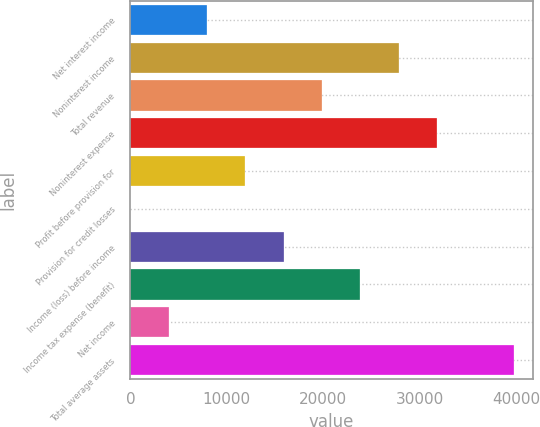Convert chart to OTSL. <chart><loc_0><loc_0><loc_500><loc_500><bar_chart><fcel>Net interest income<fcel>Noninterest income<fcel>Total revenue<fcel>Noninterest expense<fcel>Profit before provision for<fcel>Provision for credit losses<fcel>Income (loss) before income<fcel>Income tax expense (benefit)<fcel>Net income<fcel>Total average assets<nl><fcel>7958.2<fcel>27826.2<fcel>19879<fcel>31799.8<fcel>11931.8<fcel>11<fcel>15905.4<fcel>23852.6<fcel>3984.6<fcel>39747<nl></chart> 